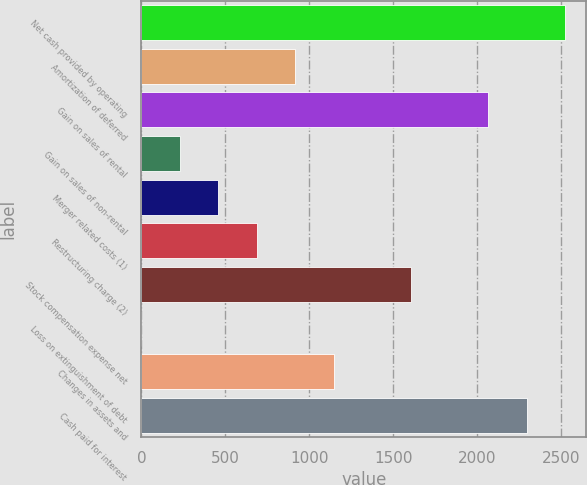Convert chart to OTSL. <chart><loc_0><loc_0><loc_500><loc_500><bar_chart><fcel>Net cash provided by operating<fcel>Amortization of deferred<fcel>Gain on sales of rental<fcel>Gain on sales of non-rental<fcel>Merger related costs (1)<fcel>Restructuring charge (2)<fcel>Stock compensation expense net<fcel>Loss on extinguishment of debt<fcel>Changes in assets and<fcel>Cash paid for interest<nl><fcel>2522.2<fcel>917.8<fcel>2063.8<fcel>230.2<fcel>459.4<fcel>688.6<fcel>1605.4<fcel>1<fcel>1147<fcel>2293<nl></chart> 